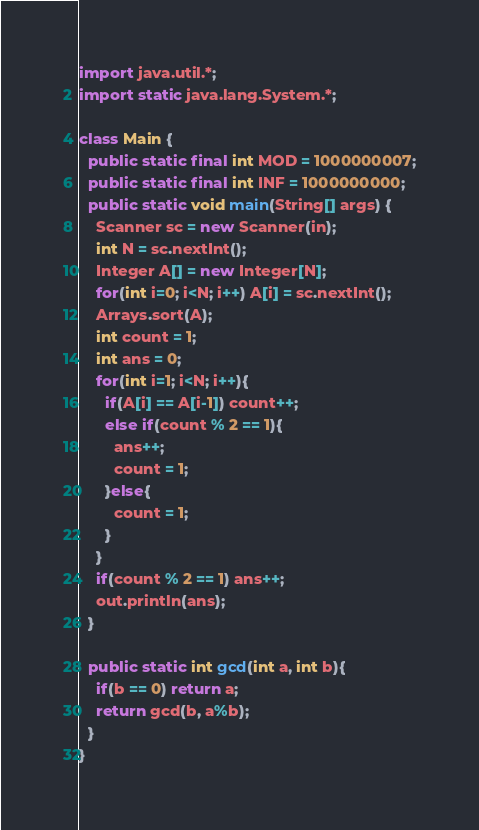Convert code to text. <code><loc_0><loc_0><loc_500><loc_500><_Java_>import java.util.*;
import static java.lang.System.*;

class Main {
  public static final int MOD = 1000000007;
  public static final int INF = 1000000000;
  public static void main(String[] args) {
    Scanner sc = new Scanner(in);
    int N = sc.nextInt();
    Integer A[] = new Integer[N];
    for(int i=0; i<N; i++) A[i] = sc.nextInt();
    Arrays.sort(A);
    int count = 1;
    int ans = 0;
    for(int i=1; i<N; i++){
      if(A[i] == A[i-1]) count++;
      else if(count % 2 == 1){
        ans++;
        count = 1;
      }else{
        count = 1;
      }
    }
    if(count % 2 == 1) ans++;
    out.println(ans);
  }

  public static int gcd(int a, int b){
    if(b == 0) return a;
    return gcd(b, a%b);
  }
}</code> 